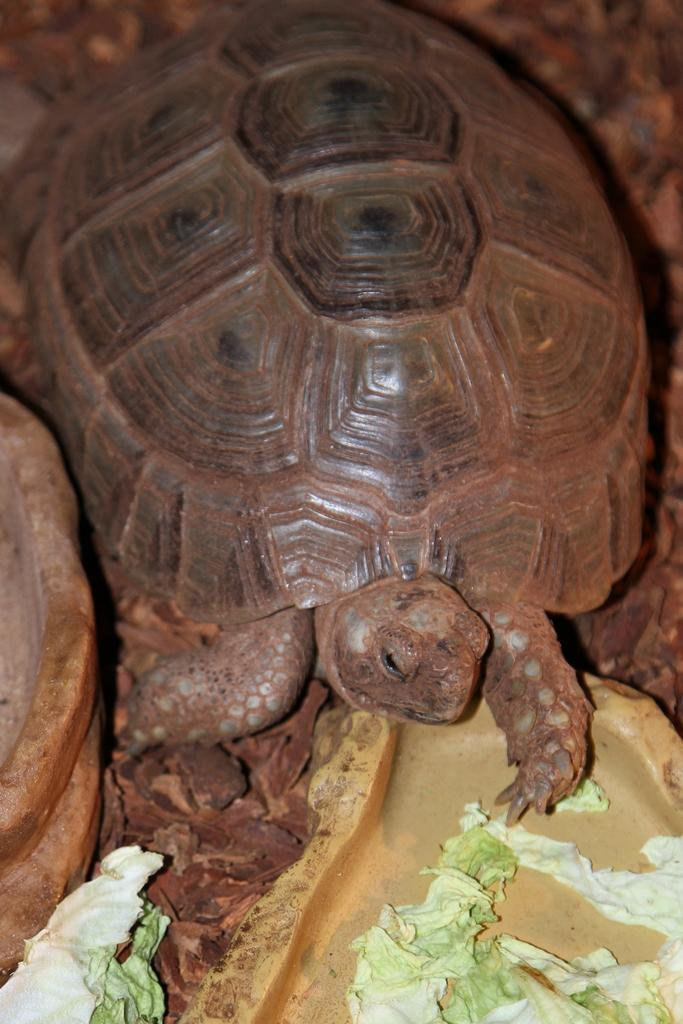What type of animal is in the image? There is a tortoise in the image. What is located at the bottom of the image? There are cabbage leaves at the bottom of the image. What object resembles a rock in the image? There is an object that resembles a rock on the left side of the image. What type of grain is being harvested by the visitor in the image? There is no visitor or grain present in the image; it only features a tortoise, cabbage leaves, and a rock-like object. 